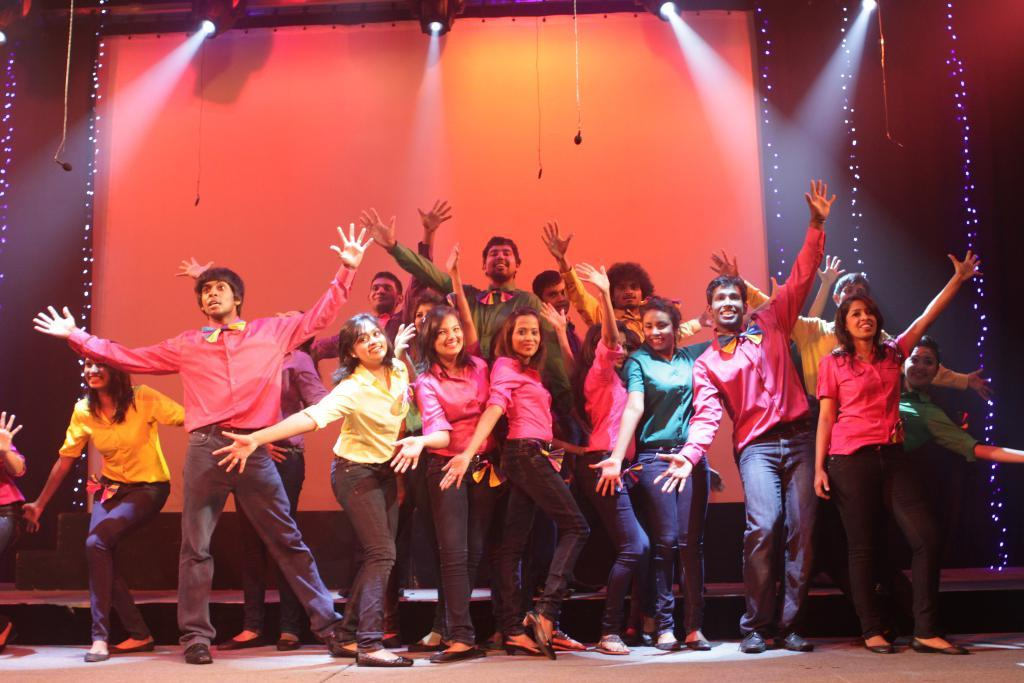How many people are in the image? There is a group of people standing in the image. Where are the people standing? The people are standing on the floor. What can be seen in the image besides the people? There are lights, a wall, and a display screen visible in the image. What type of fruit is being used to write on the chalkboard in the image? There is no chalkboard or fruit present in the image. 